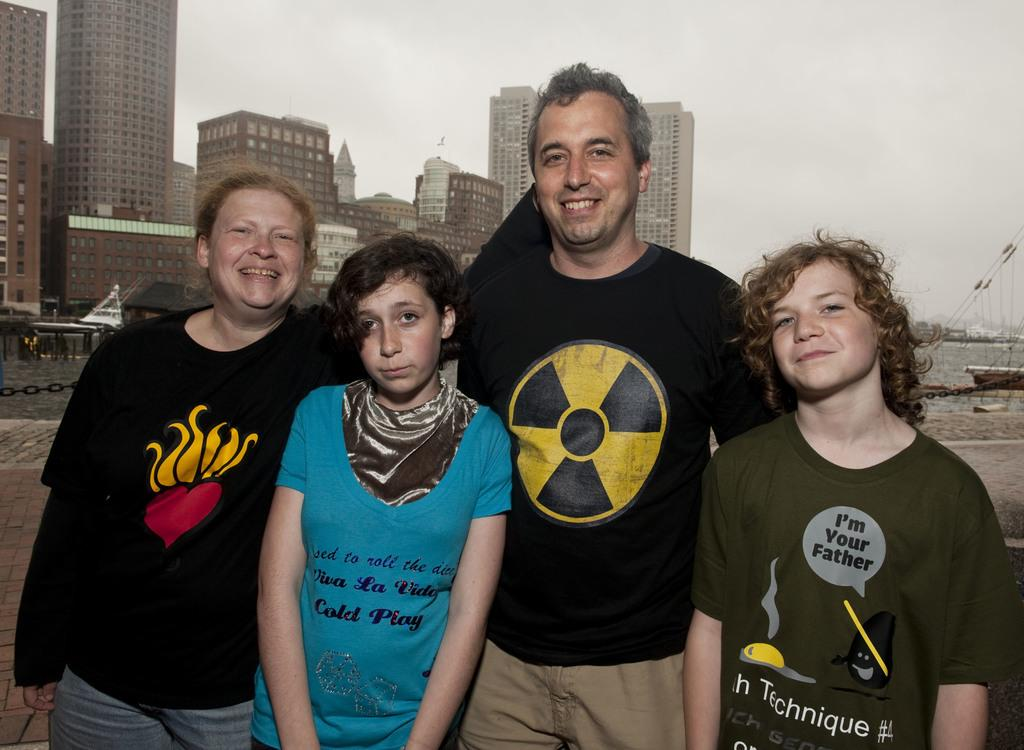How many people are present in the image? There are 4 people in the image. What is the facial expression of some of the people in the image? Some of the people are smiling. What can be seen in the background of the image? There are buildings, boats on the water, and other objects in the background of the image. What part of the natural environment is visible in the image? The sky is visible in the background of the image. What type of lumber is being transported by the boats in the image? There is no indication of any lumber being transported by the boats in the image. Can you see any veins in the people's faces in the image? The image does not provide enough detail to see individual veins in the people's faces. 